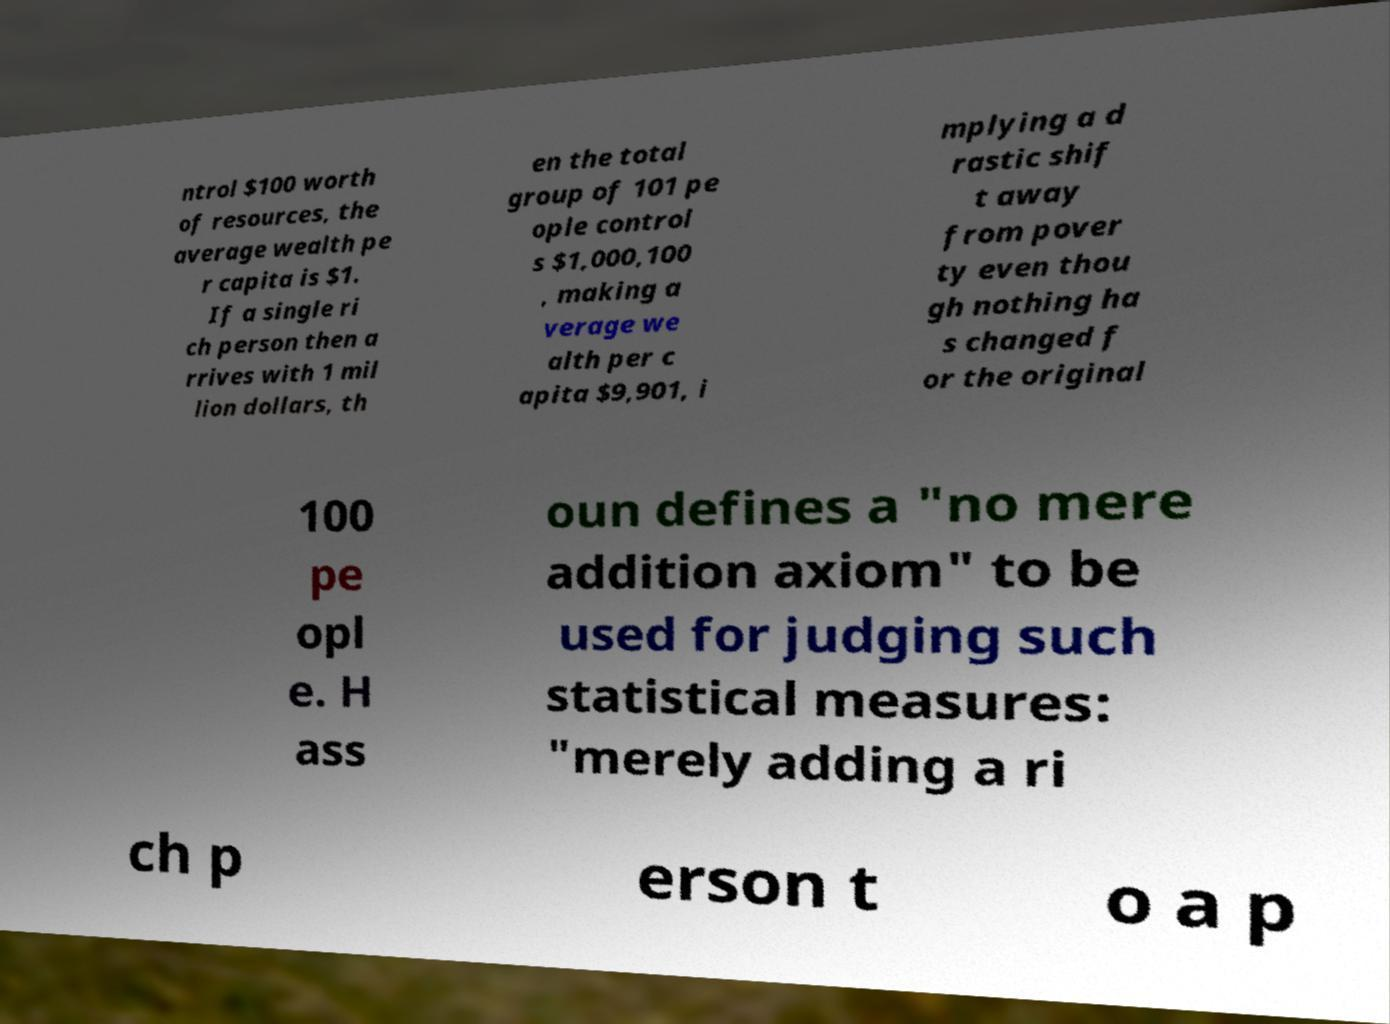Please read and relay the text visible in this image. What does it say? ntrol $100 worth of resources, the average wealth pe r capita is $1. If a single ri ch person then a rrives with 1 mil lion dollars, th en the total group of 101 pe ople control s $1,000,100 , making a verage we alth per c apita $9,901, i mplying a d rastic shif t away from pover ty even thou gh nothing ha s changed f or the original 100 pe opl e. H ass oun defines a "no mere addition axiom" to be used for judging such statistical measures: "merely adding a ri ch p erson t o a p 